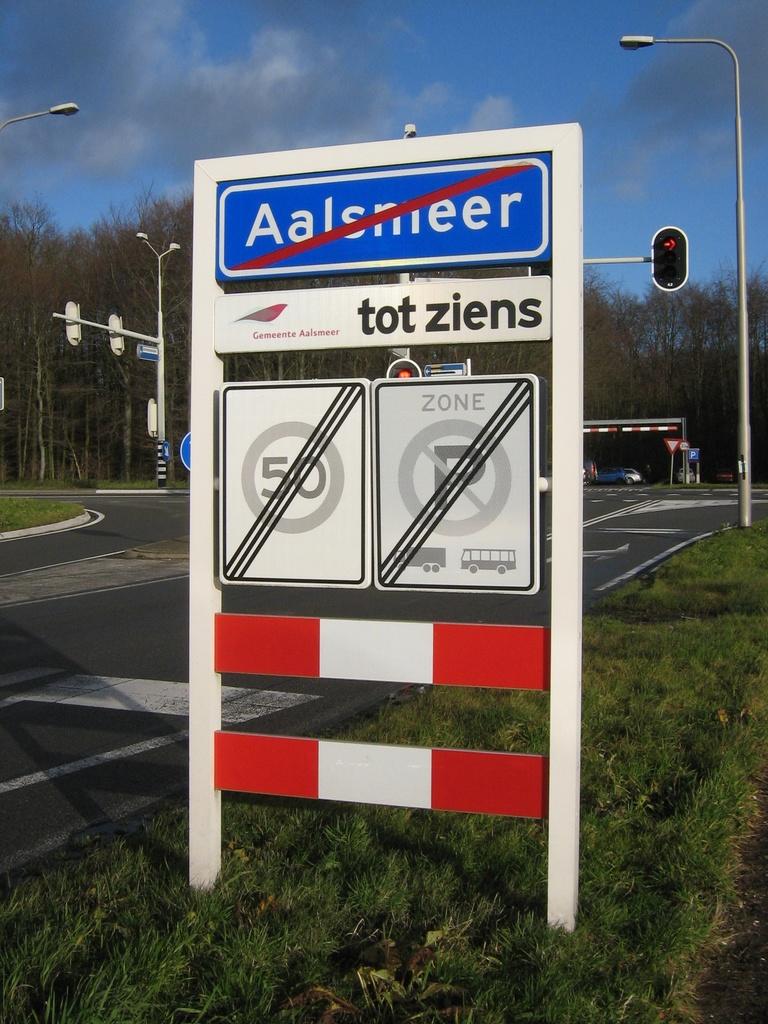What number is not allowed on this road?
Offer a terse response. 50. 